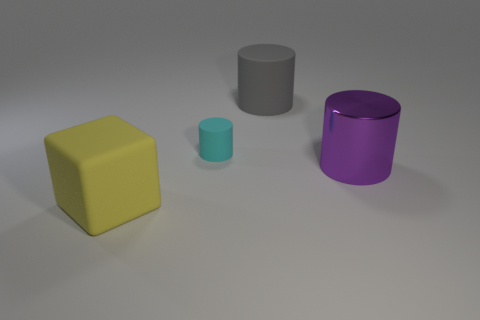Add 1 cyan matte things. How many objects exist? 5 Subtract all cubes. How many objects are left? 3 Subtract 0 green spheres. How many objects are left? 4 Subtract all big gray shiny cylinders. Subtract all cubes. How many objects are left? 3 Add 1 large yellow objects. How many large yellow objects are left? 2 Add 4 large blue rubber blocks. How many large blue rubber blocks exist? 4 